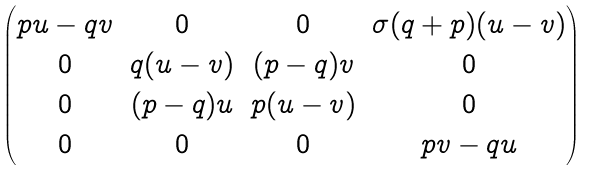Convert formula to latex. <formula><loc_0><loc_0><loc_500><loc_500>\begin{pmatrix} p u - q v & 0 & 0 & \sigma ( q + p ) ( u - v ) \\ 0 & q ( u - v ) & ( p - q ) v & 0 \\ 0 & ( p - q ) u & p ( u - v ) & 0 \\ 0 & 0 & 0 & p v - q u \end{pmatrix}</formula> 